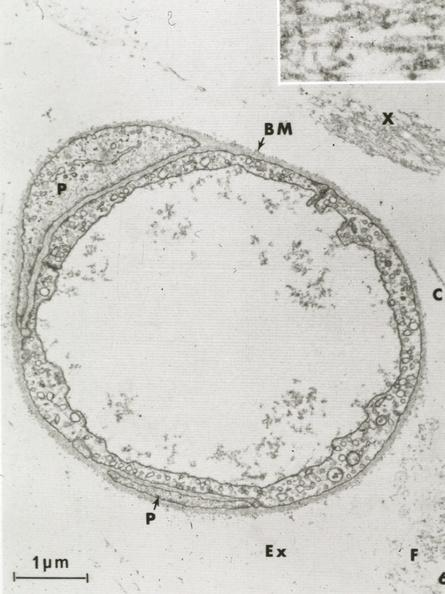what does this image show?
Answer the question using a single word or phrase. Continuous type 